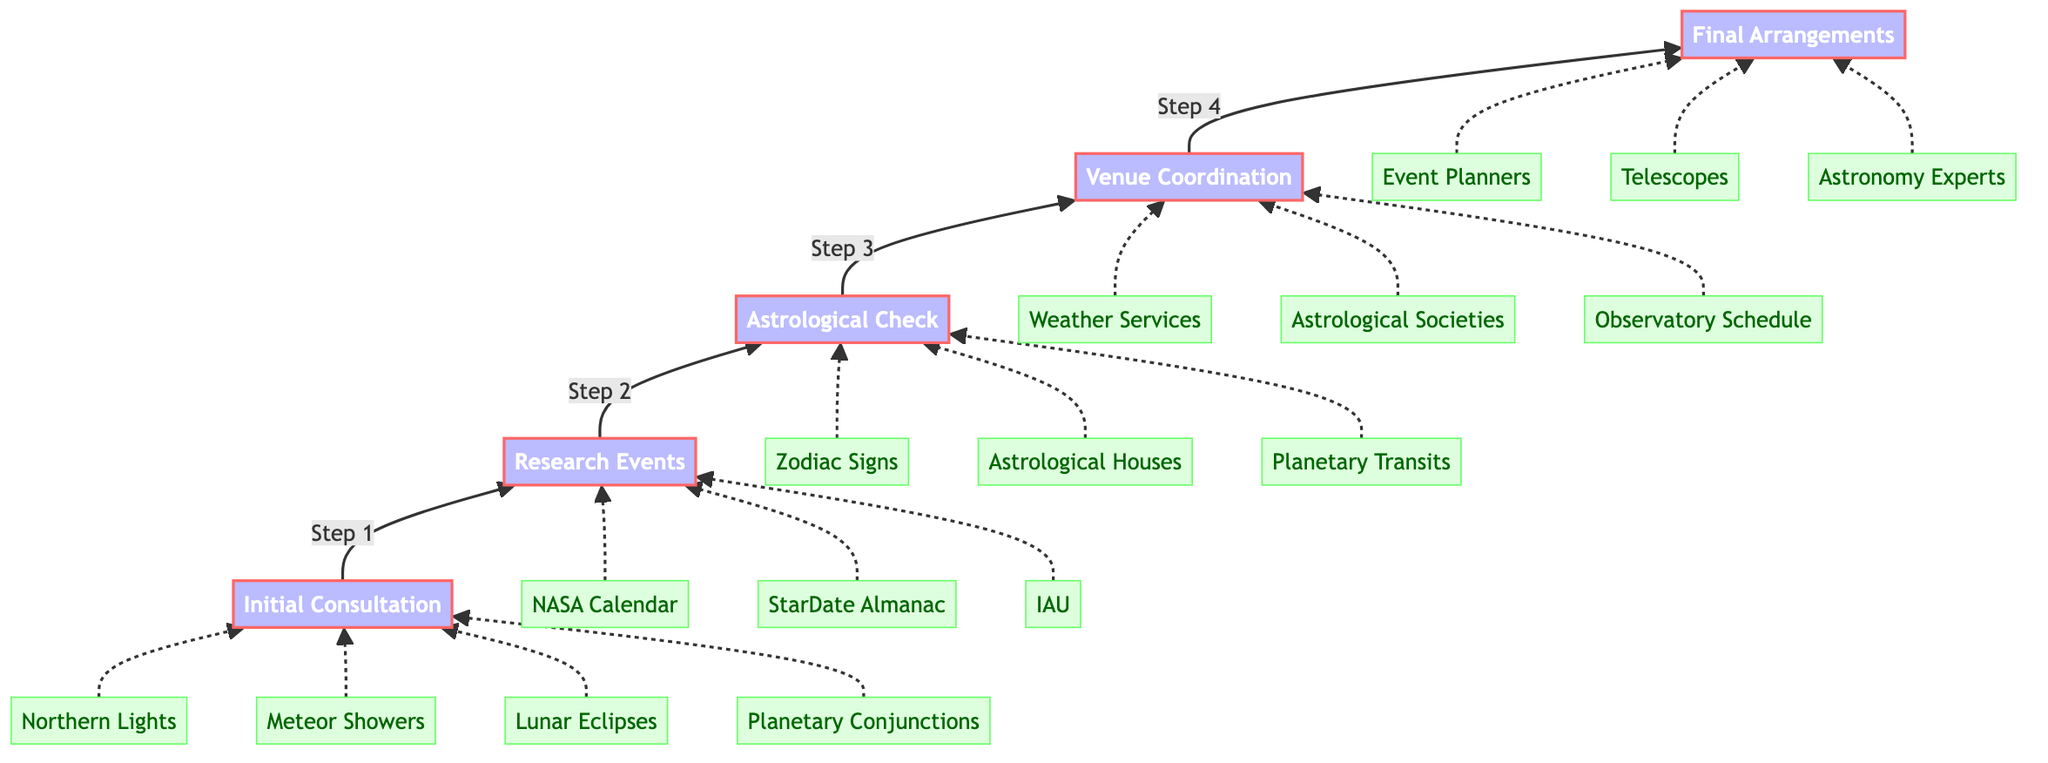What is the first step in the process? The first step in the flow chart is represented at the bottom, labeled "Initial Consultation with Couple." This is the starting point of the flow that guides the subsequent steps.
Answer: Initial Consultation with Couple How many total steps are there? The flow chart displays a total of five distinct steps, from the initial consultation to the final arrangements. This count is derived by observing the labeled nodes in the chart.
Answer: 5 Which celestial event is associated with step one? Step one, "Initial Consultation with Couple," has several associated celestial events listed as entities. These include "Northern Lights," "Meteor Showers," "Lunar Eclipses," and "Planetary Conjunctions." Among these, any one can be specified, but I will take "Northern Lights" for this answer.
Answer: Northern Lights What is the title of the fourth step? The fourth step is labeled "Venue and Date Coordination." This title is clearly marked in the diagram, representing the specific action taken at this stage of the process.
Answer: Venue and Date Coordination Which entities are researched in step two? In step two, "Research Celestial Events Calendar," three entities are specified: "NASA Calendar," "StarDate Almanac," and "International Astronomical Union." These are directly connected to the second step in the diagram.
Answer: NASA Calendar, StarDate Almanac, International Astronomical Union What is the final step in the process? The last step, at the top of the flow chart, is labeled "Booking and Final Arrangements." This signifies the completion of the process after all prior steps have been accomplished.
Answer: Booking and Final Arrangements How does one move from step three to step four? Moving from step three, "Astrological Compatibility Check," to step four, "Venue Coordination," follows a direct upward flow indicated by an arrow connecting these two steps. This shows the progression from checking compatibility to coordinating the venue.
Answer: Through a direct upward flow arrow What is the purpose of the "Astrological Compatibility Check"? The purpose of the "Astrological Compatibility Check" is to ensure chosen celestial events align with the couple's astrological signs and personalities. This step is crucial in making the wedding significant according to the couple's beliefs.
Answer: Ensure alignment with astrological signs Which step involves weather predictions? The step involving "Weather Predictions" is the fourth step, titled "Venue and Date Coordination." This is where venue availability and weather forecasts are critical for the event's success.
Answer: Venue and Date Coordination 